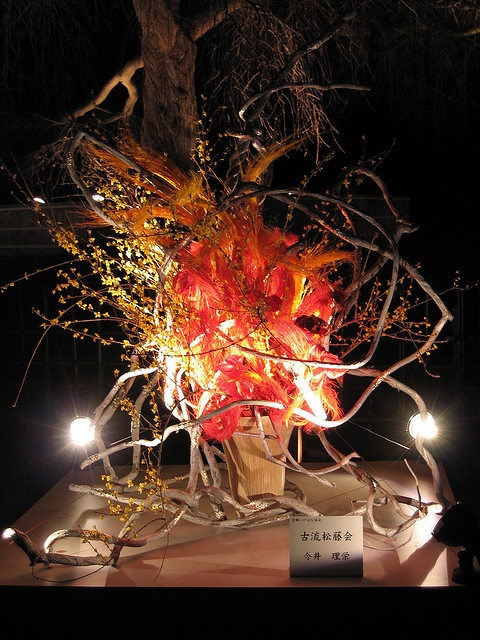Describe the objects in this image and their specific colors. I can see a vase in black, tan, brown, maroon, and salmon tones in this image. 